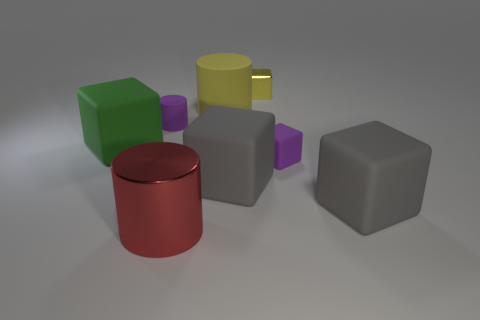Is there any other thing that is the same color as the tiny cylinder?
Ensure brevity in your answer.  Yes. How many big things are either cyan rubber blocks or green matte cubes?
Offer a terse response. 1. Are there more small yellow objects than red matte blocks?
Your answer should be compact. Yes. What is the size of the green thing that is the same material as the big yellow cylinder?
Your answer should be compact. Large. Is the size of the cylinder that is to the left of the big metal cylinder the same as the purple thing that is in front of the tiny purple matte cylinder?
Your answer should be very brief. Yes. What number of things are either small rubber things on the left side of the purple cube or big red rubber cubes?
Provide a short and direct response. 1. Is the number of small purple cubes less than the number of big gray rubber blocks?
Provide a short and direct response. Yes. There is a large rubber thing that is left of the big rubber object behind the purple object left of the large red object; what is its shape?
Your answer should be compact. Cube. There is a matte thing that is the same color as the small cylinder; what shape is it?
Make the answer very short. Cube. Are there any big yellow objects?
Provide a short and direct response. Yes. 